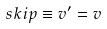<formula> <loc_0><loc_0><loc_500><loc_500>s k i p \equiv v ^ { \prime } = v</formula> 